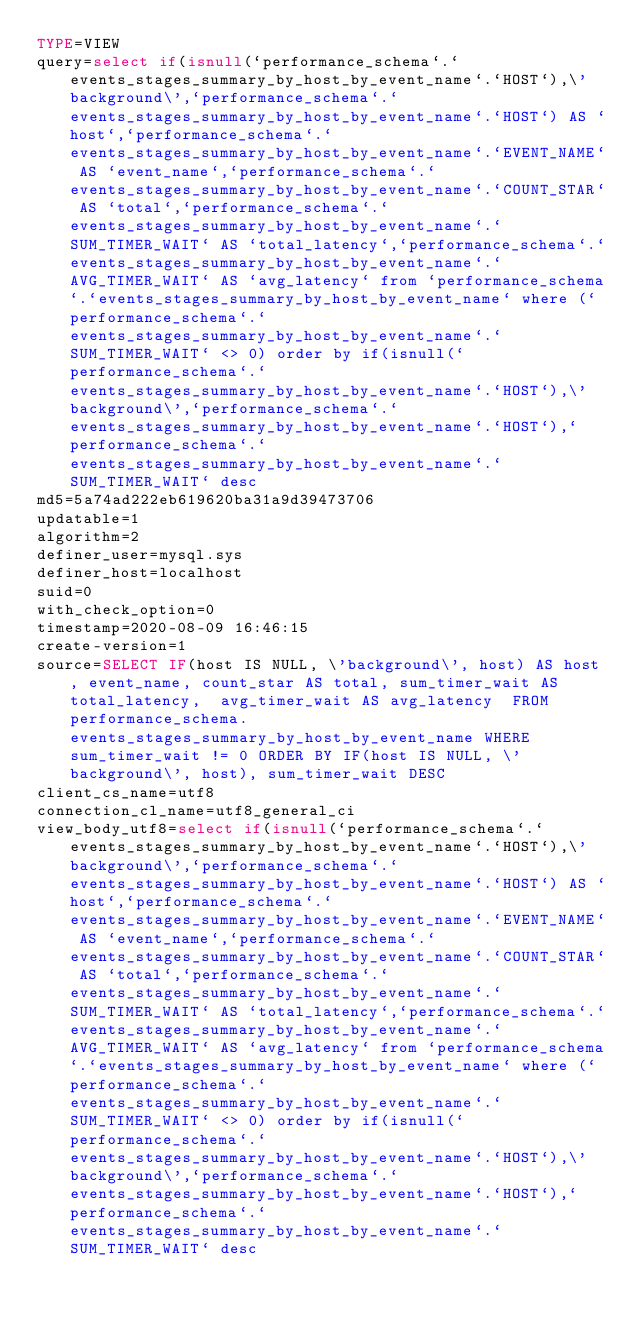Convert code to text. <code><loc_0><loc_0><loc_500><loc_500><_VisualBasic_>TYPE=VIEW
query=select if(isnull(`performance_schema`.`events_stages_summary_by_host_by_event_name`.`HOST`),\'background\',`performance_schema`.`events_stages_summary_by_host_by_event_name`.`HOST`) AS `host`,`performance_schema`.`events_stages_summary_by_host_by_event_name`.`EVENT_NAME` AS `event_name`,`performance_schema`.`events_stages_summary_by_host_by_event_name`.`COUNT_STAR` AS `total`,`performance_schema`.`events_stages_summary_by_host_by_event_name`.`SUM_TIMER_WAIT` AS `total_latency`,`performance_schema`.`events_stages_summary_by_host_by_event_name`.`AVG_TIMER_WAIT` AS `avg_latency` from `performance_schema`.`events_stages_summary_by_host_by_event_name` where (`performance_schema`.`events_stages_summary_by_host_by_event_name`.`SUM_TIMER_WAIT` <> 0) order by if(isnull(`performance_schema`.`events_stages_summary_by_host_by_event_name`.`HOST`),\'background\',`performance_schema`.`events_stages_summary_by_host_by_event_name`.`HOST`),`performance_schema`.`events_stages_summary_by_host_by_event_name`.`SUM_TIMER_WAIT` desc
md5=5a74ad222eb619620ba31a9d39473706
updatable=1
algorithm=2
definer_user=mysql.sys
definer_host=localhost
suid=0
with_check_option=0
timestamp=2020-08-09 16:46:15
create-version=1
source=SELECT IF(host IS NULL, \'background\', host) AS host, event_name, count_star AS total, sum_timer_wait AS total_latency,  avg_timer_wait AS avg_latency  FROM performance_schema.events_stages_summary_by_host_by_event_name WHERE sum_timer_wait != 0 ORDER BY IF(host IS NULL, \'background\', host), sum_timer_wait DESC
client_cs_name=utf8
connection_cl_name=utf8_general_ci
view_body_utf8=select if(isnull(`performance_schema`.`events_stages_summary_by_host_by_event_name`.`HOST`),\'background\',`performance_schema`.`events_stages_summary_by_host_by_event_name`.`HOST`) AS `host`,`performance_schema`.`events_stages_summary_by_host_by_event_name`.`EVENT_NAME` AS `event_name`,`performance_schema`.`events_stages_summary_by_host_by_event_name`.`COUNT_STAR` AS `total`,`performance_schema`.`events_stages_summary_by_host_by_event_name`.`SUM_TIMER_WAIT` AS `total_latency`,`performance_schema`.`events_stages_summary_by_host_by_event_name`.`AVG_TIMER_WAIT` AS `avg_latency` from `performance_schema`.`events_stages_summary_by_host_by_event_name` where (`performance_schema`.`events_stages_summary_by_host_by_event_name`.`SUM_TIMER_WAIT` <> 0) order by if(isnull(`performance_schema`.`events_stages_summary_by_host_by_event_name`.`HOST`),\'background\',`performance_schema`.`events_stages_summary_by_host_by_event_name`.`HOST`),`performance_schema`.`events_stages_summary_by_host_by_event_name`.`SUM_TIMER_WAIT` desc
</code> 